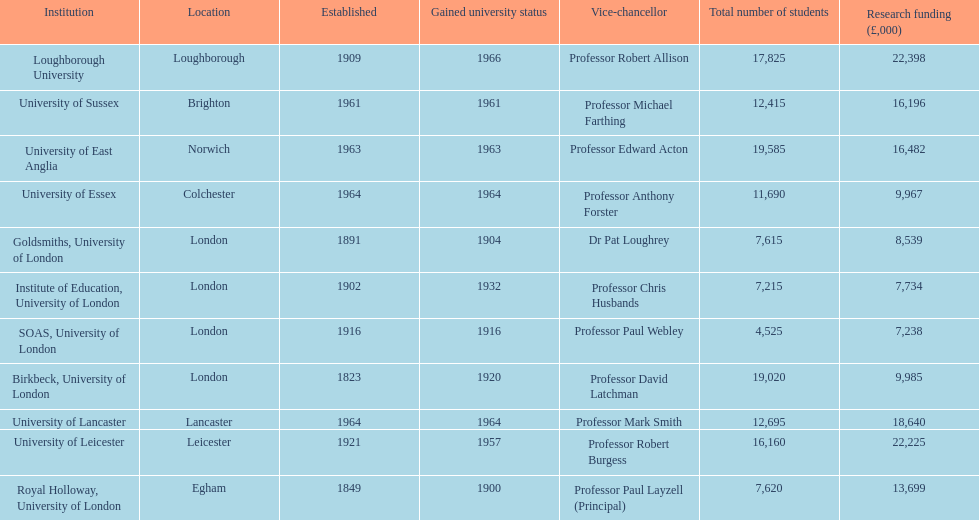How many of the institutions are located in london? 4. 